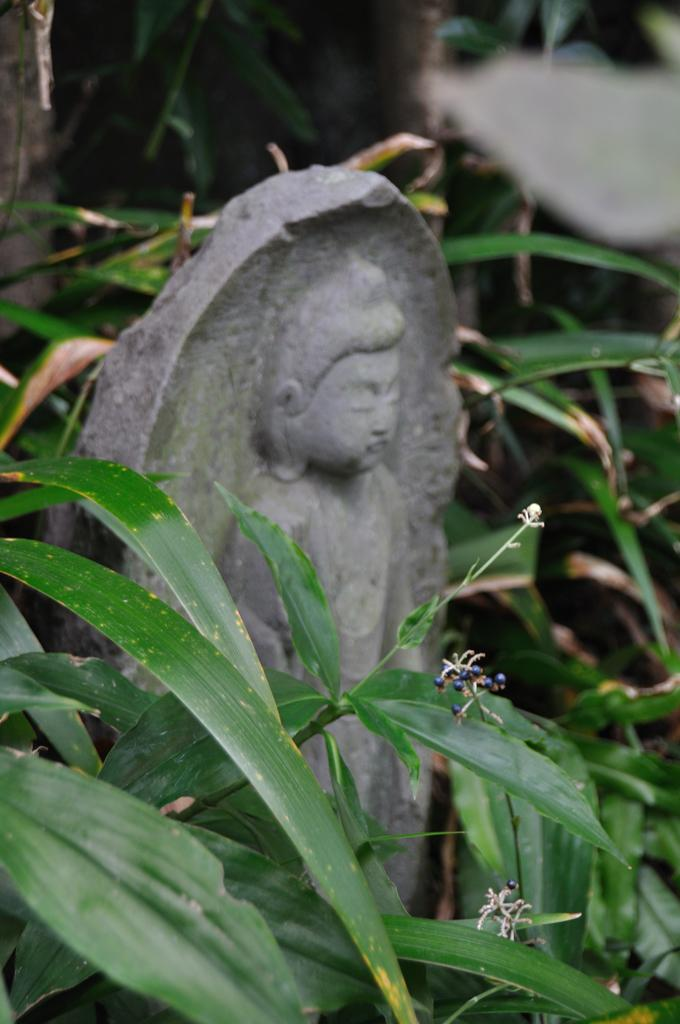What is the main subject of the image? The main subject of the image is an idol made up of rock. What can be seen at the bottom of the image? There are plants visible at the bottom of the image. What is visible in the background of the image? There appears to be a tree in the background of the image. What type of shoe can be seen on the idol's foot in the image? There is no shoe present on the idol's foot in the image, as the idol is made up of rock and does not have feet. 